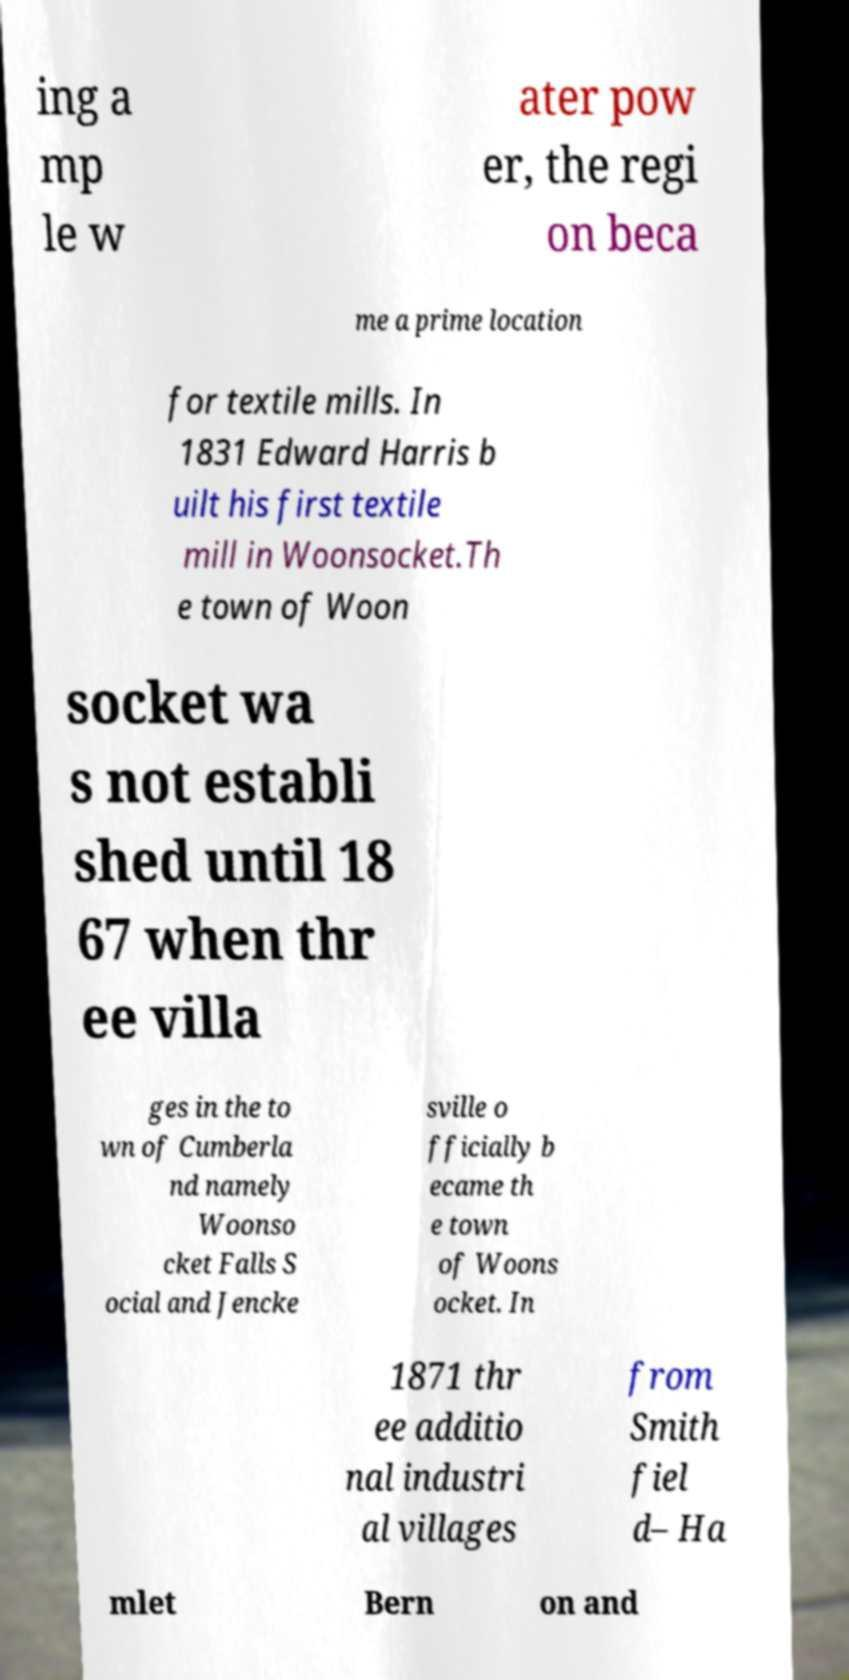Please identify and transcribe the text found in this image. ing a mp le w ater pow er, the regi on beca me a prime location for textile mills. In 1831 Edward Harris b uilt his first textile mill in Woonsocket.Th e town of Woon socket wa s not establi shed until 18 67 when thr ee villa ges in the to wn of Cumberla nd namely Woonso cket Falls S ocial and Jencke sville o fficially b ecame th e town of Woons ocket. In 1871 thr ee additio nal industri al villages from Smith fiel d– Ha mlet Bern on and 